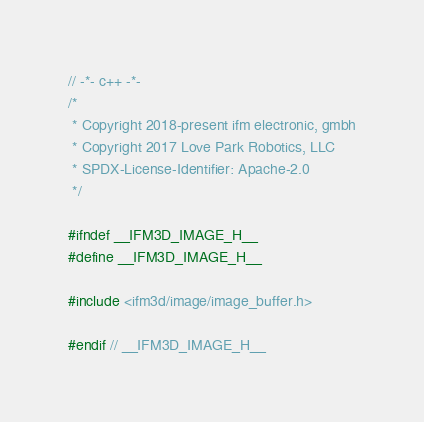<code> <loc_0><loc_0><loc_500><loc_500><_C_>// -*- c++ -*-
/*
 * Copyright 2018-present ifm electronic, gmbh
 * Copyright 2017 Love Park Robotics, LLC
 * SPDX-License-Identifier: Apache-2.0
 */

#ifndef __IFM3D_IMAGE_H__
#define __IFM3D_IMAGE_H__

#include <ifm3d/image/image_buffer.h>

#endif // __IFM3D_IMAGE_H__
</code> 